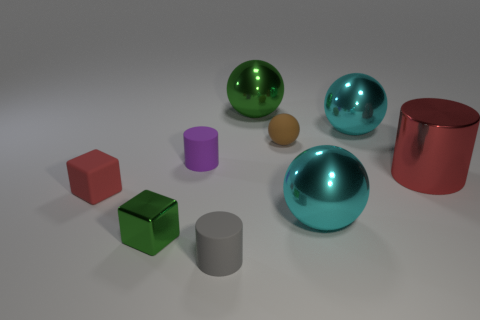Is there a cube made of the same material as the tiny purple object?
Your answer should be very brief. Yes. The thing that is the same color as the rubber block is what size?
Your answer should be very brief. Large. What number of cylinders are large green objects or large cyan objects?
Your answer should be very brief. 0. What is the size of the metal cube?
Offer a terse response. Small. How many small cylinders are behind the gray matte thing?
Offer a very short reply. 1. There is a shiny sphere in front of the red metallic cylinder that is in front of the tiny brown rubber thing; how big is it?
Your answer should be very brief. Large. Does the small object that is on the right side of the large green metallic object have the same shape as the green shiny thing that is to the right of the small metal thing?
Your response must be concise. Yes. There is a tiny object to the right of the thing that is in front of the green metal block; what is its shape?
Your response must be concise. Sphere. How big is the metal thing that is behind the small rubber block and in front of the small purple cylinder?
Your answer should be compact. Large. Do the large red thing and the big thing that is in front of the small matte cube have the same shape?
Offer a very short reply. No. 